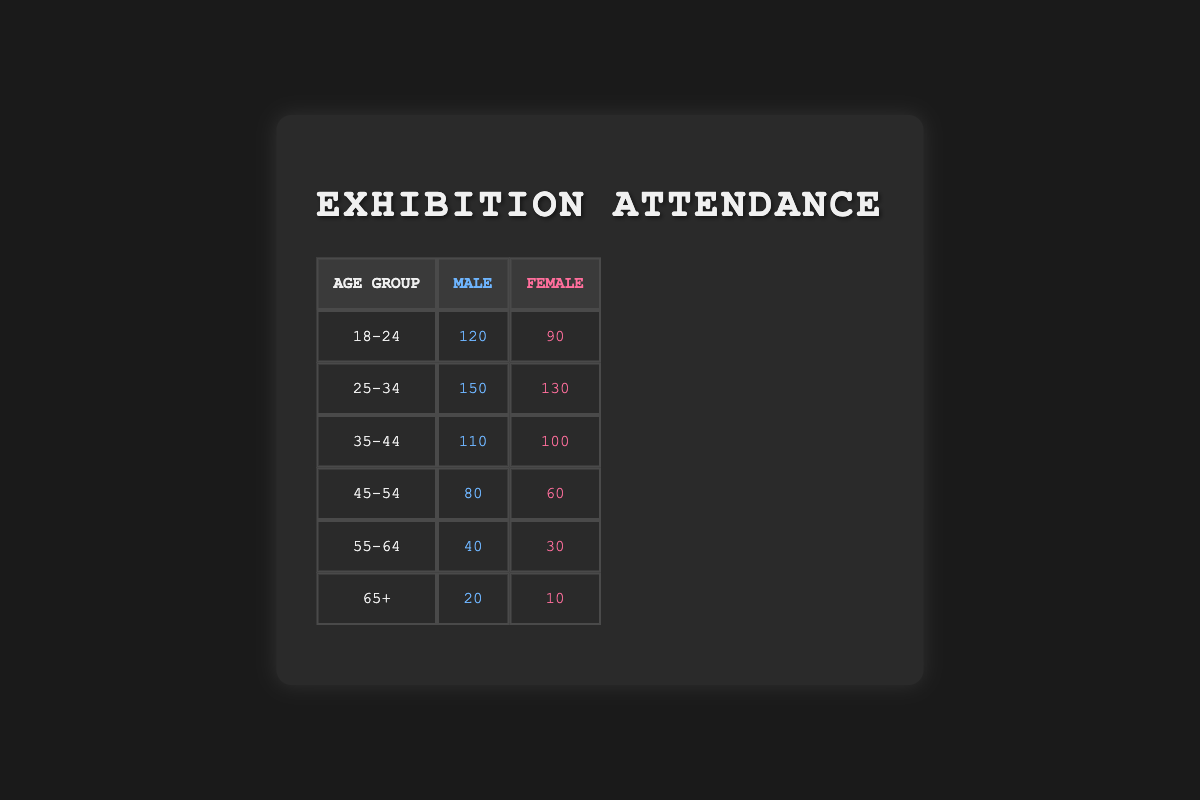What is the attendance number for females aged 25-34? The table shows a specific row for the age group 25-34 and gender female, which lists an attendance of 130.
Answer: 130 Which age group had the highest male attendance? By reviewing the male attendance data across all age groups, 25-34 shows the highest attendance at 150, compared to other age groups.
Answer: 25-34 What is the total female attendance across all age groups? To find the total female attendance, we sum the female attendance values: 90 + 130 + 100 + 60 + 30 + 10 = 420.
Answer: 420 Is the attendance for females in the 18-24 age group greater than that for males in the 55-64 age group? The attendance for females aged 18-24 is 90, while for males aged 55-64, it is 40. Since 90 is greater than 40, the statement is true.
Answer: Yes What is the difference in attendance between males and females in the 45-54 age group? For the 45-54 age group, male attendance is 80 and female attendance is 60. The difference is calculated as 80 - 60 = 20.
Answer: 20 Which age group has the lowest overall attendance? By reviewing both male and female attendance totals per age group, the 65+ age group's total (20 + 10 = 30) is the lowest compared to others, which are higher.
Answer: 65+ What is the average attendance for males across all age groups? To find the average attendance for males, we sum their attendance: 120 + 150 + 110 + 80 + 40 + 20 = 520. There are 6 age groups, so the average is 520 / 6 ≈ 86.67.
Answer: 86.67 In which age group is the attendance for females closest to the attendance for males? By examining the attendance numbers, for the age group 35-44, male attendance is 110 and female attendance is 100, with a difference of only 10, which is close compared to other age groups.
Answer: 35-44 Is the total attendance for the 55-64 age group less than the total for the 45-54 age group? The total attendance for 55-64 is 40 + 30 = 70, while for 45-54 it is 80 + 60 = 140. Since 70 is less than 140, the statement is true.
Answer: Yes 